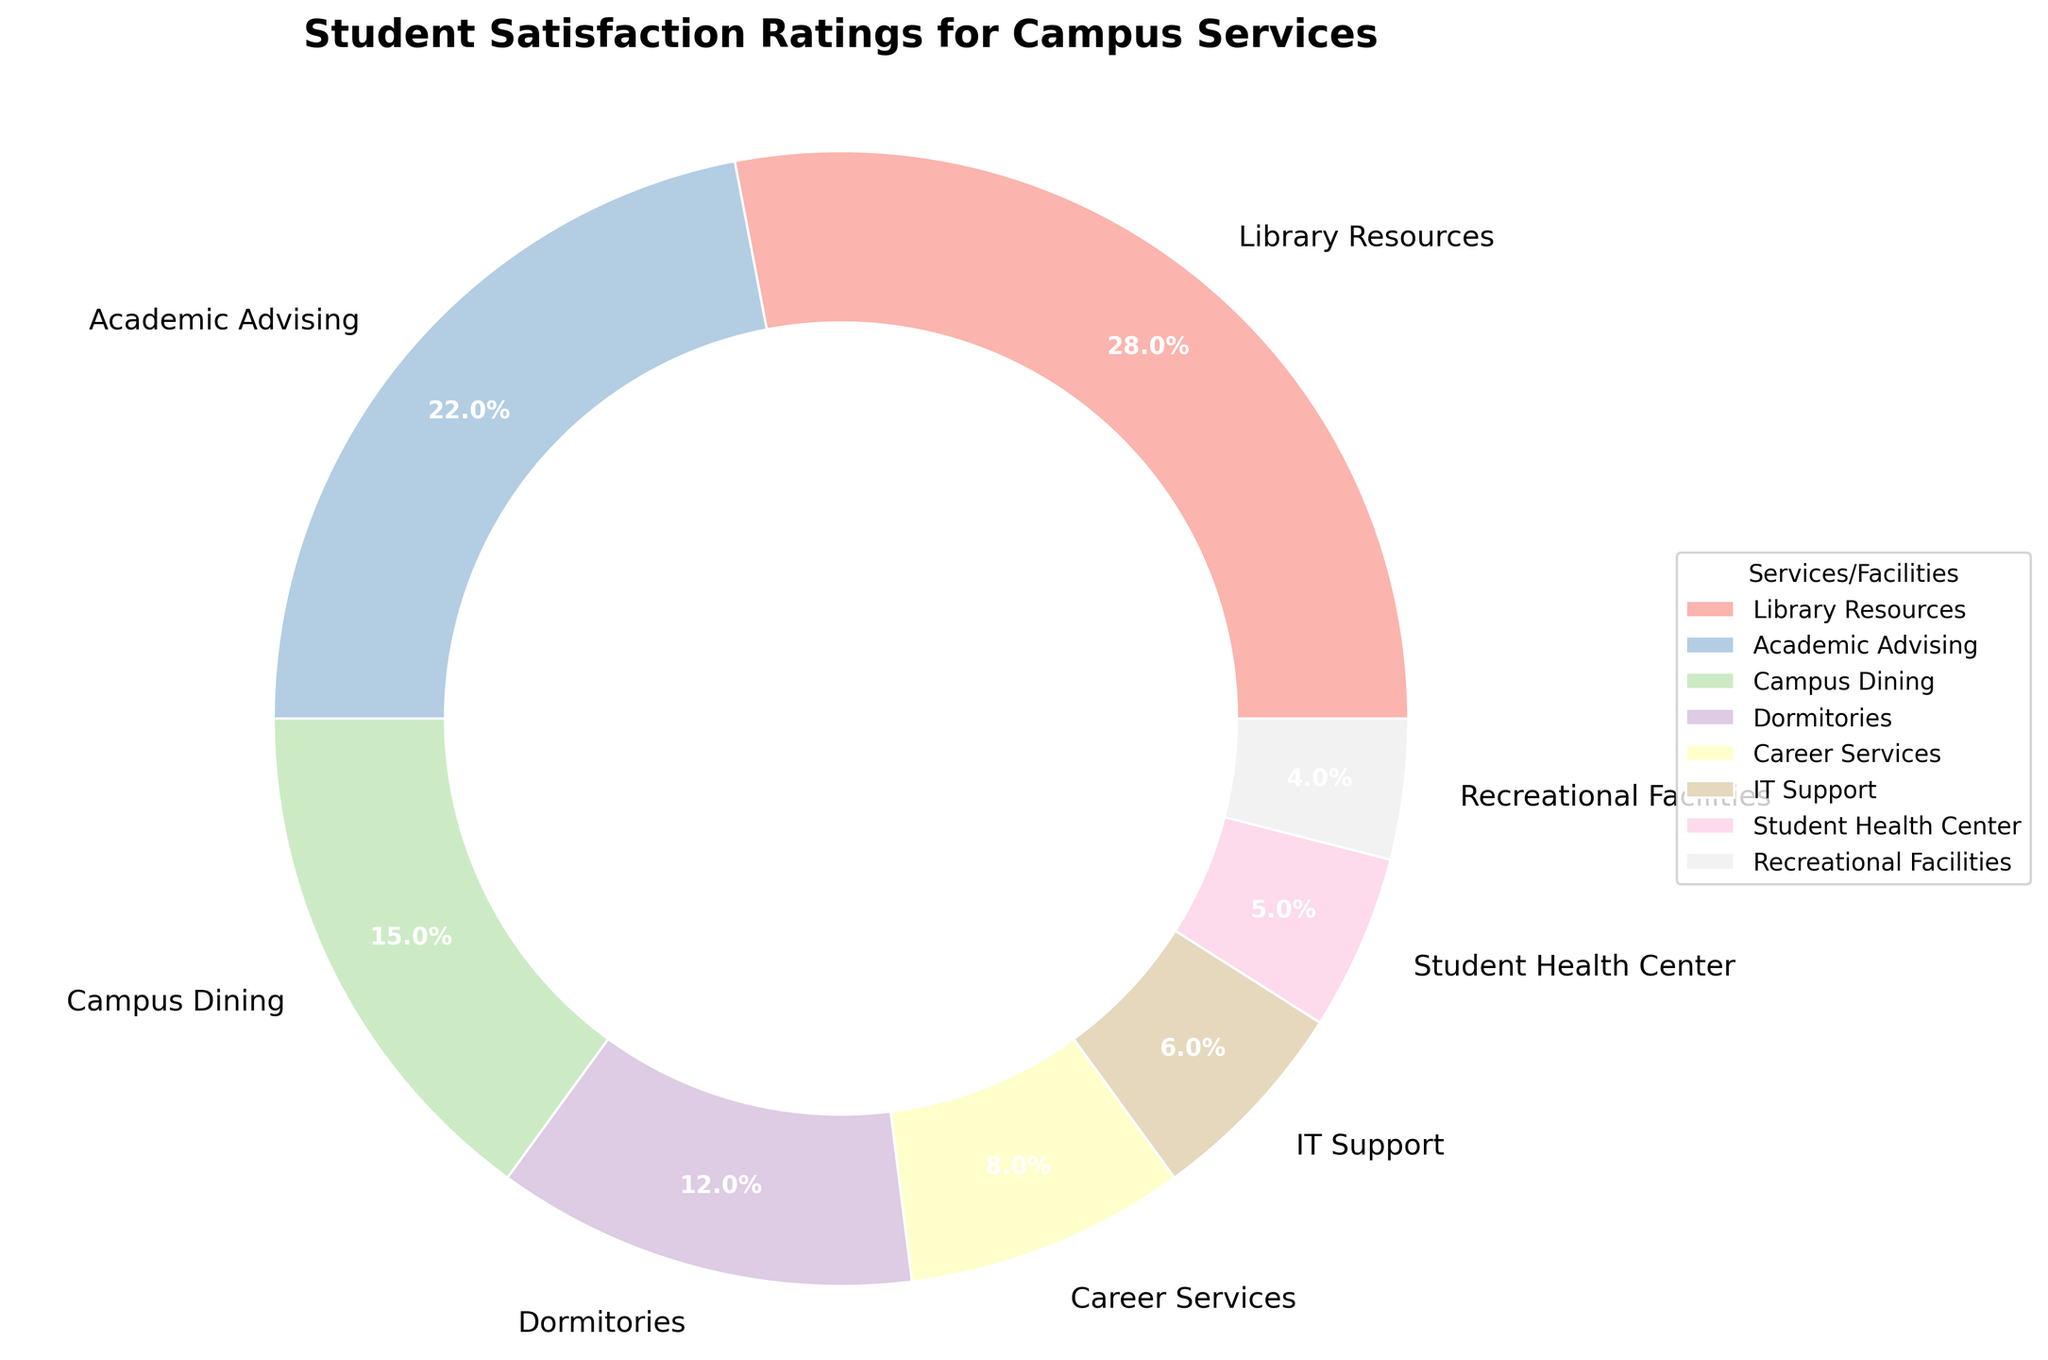Which service/facility has the highest student satisfaction percentage? The Library Resources section of the pie chart shows the largest wedge, indicating the highest satisfaction percentage at 28%.
Answer: Library Resources What is the combined satisfaction percentage for Campus Dining and Dormitories? Adding the satisfaction percentages for Campus Dining (15%) and Dormitories (12%) gives us 15% + 12% = 27%.
Answer: 27% How much greater is the satisfaction for IT Support compared to the Student Health Center? The percentage for IT Support is 6%, and the percentage for the Student Health Center is 5%. The difference is 6% - 5% = 1%.
Answer: 1% Which two services/facilities combined have the highest satisfaction percentage? The Library Resources (28%) and Academic Advising (22%) combined give the highest percentage of 28% + 22% = 50%.
Answer: Library Resources and Academic Advising How many services/facilities have a satisfaction percentage lower than Career Services? Career Services has an 8% satisfaction rating. The services/facilities below this percentage are IT Support (6%), Student Health Center (5%), and Recreational Facilities (4%). Thus, there are 3 services/facilities lower than Career Services.
Answer: 3 What is the average satisfaction percentage for Recreational Facilities, Student Health Center, and IT Support? Adding the percentages for Recreational Facilities (4%), Student Health Center (5%), and IT Support (6%) gives 4% + 5% + 6% = 15%. The average is 15% / 3 = 5%.
Answer: 5% Which service/facility constitutes exactly double the percentage of the Student Health Center? The Student Health Center has a satisfaction percentage of 5%. Double of this value is 2 * 5% = 10%. None of the services/facilities have exactly 10%, thus none.
Answer: None Is the satisfaction percentage for Academic Advising greater than the combined total for Career Services and Dormitories? The satisfaction for Academic Advising (22%) compared to the combined satisfaction of Career Services (8%) and Dormitories (12%) is 22% vs 8% + 12% = 20%. Thus, 22% is greater than 20%.
Answer: Yes What percentage of students are satisfied with the services provided by Dormitories and Recreational Facilities together? Adding the satisfaction percentages for Dormitories (12%) and Recreational Facilities (4%) gives 12% + 4% = 16%.
Answer: 16% Which services/facilities have a satisfaction percentage less than half of Library Resources? Half of the Library Resources’ satisfaction percentage (28%) is 28% / 2 = 14%. Services with less than 14% satisfaction are Campus Dining (15%), Dormitories (12%), Career Services (8%), IT Support (6%), Student Health Center (5%), and Recreational Facilities (4%).
Answer: Dormitories, Career Services, IT Support, Student Health Center, and Recreational Facilities 